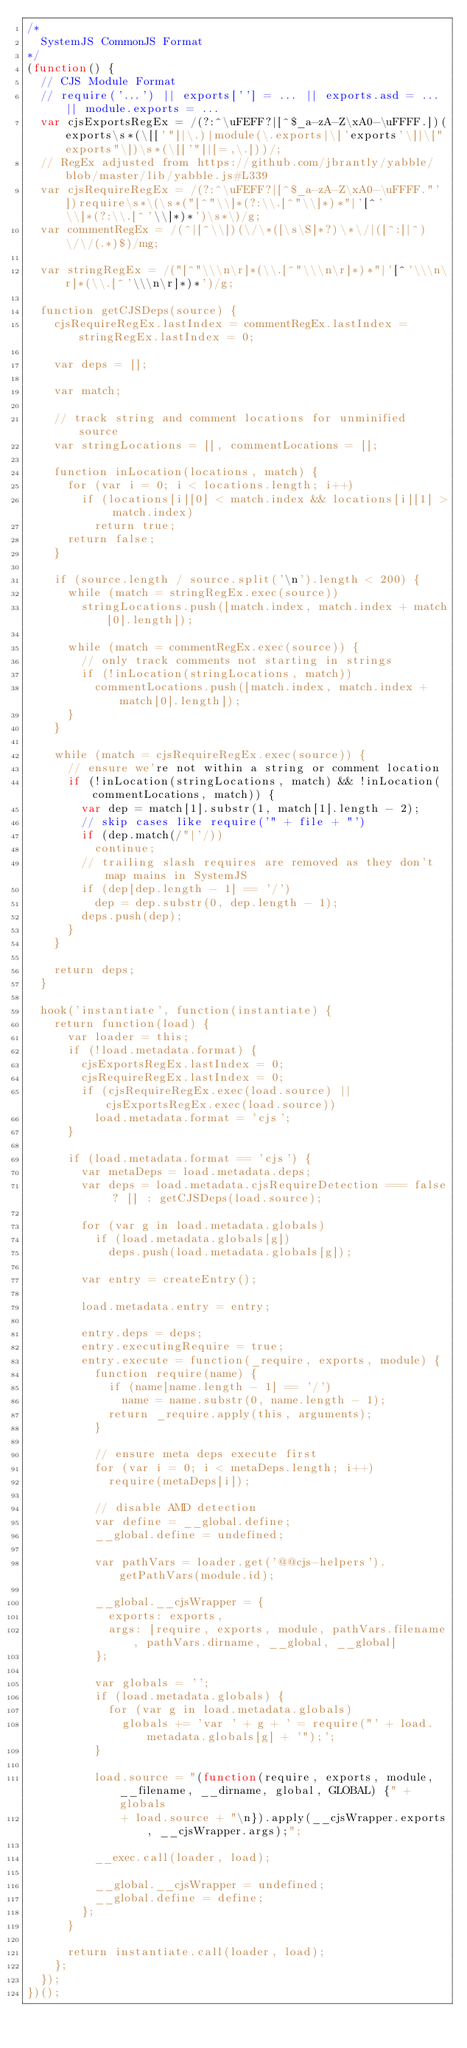Convert code to text. <code><loc_0><loc_0><loc_500><loc_500><_JavaScript_>/*
  SystemJS CommonJS Format
*/
(function() {
  // CJS Module Format
  // require('...') || exports[''] = ... || exports.asd = ... || module.exports = ...
  var cjsExportsRegEx = /(?:^\uFEFF?|[^$_a-zA-Z\xA0-\uFFFF.])(exports\s*(\[['"]|\.)|module(\.exports|\['exports'\]|\["exports"\])\s*(\[['"]|[=,\.]))/;
  // RegEx adjusted from https://github.com/jbrantly/yabble/blob/master/lib/yabble.js#L339
  var cjsRequireRegEx = /(?:^\uFEFF?|[^$_a-zA-Z\xA0-\uFFFF."'])require\s*\(\s*("[^"\\]*(?:\\.[^"\\]*)*"|'[^'\\]*(?:\\.[^'\\]*)*')\s*\)/g;
  var commentRegEx = /(^|[^\\])(\/\*([\s\S]*?)\*\/|([^:]|^)\/\/(.*)$)/mg;

  var stringRegEx = /("[^"\\\n\r]*(\\.[^"\\\n\r]*)*"|'[^'\\\n\r]*(\\.[^'\\\n\r]*)*')/g;

  function getCJSDeps(source) {
    cjsRequireRegEx.lastIndex = commentRegEx.lastIndex = stringRegEx.lastIndex = 0;

    var deps = [];

    var match;

    // track string and comment locations for unminified source    
    var stringLocations = [], commentLocations = [];

    function inLocation(locations, match) {
      for (var i = 0; i < locations.length; i++)
        if (locations[i][0] < match.index && locations[i][1] > match.index)
          return true;
      return false;
    }

    if (source.length / source.split('\n').length < 200) {
      while (match = stringRegEx.exec(source))
        stringLocations.push([match.index, match.index + match[0].length]);
      
      while (match = commentRegEx.exec(source)) {
        // only track comments not starting in strings
        if (!inLocation(stringLocations, match))
          commentLocations.push([match.index, match.index + match[0].length]);
      }
    }

    while (match = cjsRequireRegEx.exec(source)) {
      // ensure we're not within a string or comment location
      if (!inLocation(stringLocations, match) && !inLocation(commentLocations, match)) {
        var dep = match[1].substr(1, match[1].length - 2);
        // skip cases like require('" + file + "')
        if (dep.match(/"|'/))
          continue;
        // trailing slash requires are removed as they don't map mains in SystemJS
        if (dep[dep.length - 1] == '/')
          dep = dep.substr(0, dep.length - 1);
        deps.push(dep);
      }
    }

    return deps;
  }

  hook('instantiate', function(instantiate) {
    return function(load) {
      var loader = this;
      if (!load.metadata.format) {
        cjsExportsRegEx.lastIndex = 0;
        cjsRequireRegEx.lastIndex = 0;
        if (cjsRequireRegEx.exec(load.source) || cjsExportsRegEx.exec(load.source))
          load.metadata.format = 'cjs';
      }

      if (load.metadata.format == 'cjs') {
        var metaDeps = load.metadata.deps;
        var deps = load.metadata.cjsRequireDetection === false ? [] : getCJSDeps(load.source);

        for (var g in load.metadata.globals)
          if (load.metadata.globals[g])
            deps.push(load.metadata.globals[g]);

        var entry = createEntry();

        load.metadata.entry = entry;

        entry.deps = deps;
        entry.executingRequire = true;
        entry.execute = function(_require, exports, module) {
          function require(name) {
            if (name[name.length - 1] == '/')
              name = name.substr(0, name.length - 1);
            return _require.apply(this, arguments);
          }

          // ensure meta deps execute first
          for (var i = 0; i < metaDeps.length; i++)
            require(metaDeps[i]);

          // disable AMD detection
          var define = __global.define;
          __global.define = undefined;

          var pathVars = loader.get('@@cjs-helpers').getPathVars(module.id);

          __global.__cjsWrapper = {
            exports: exports,
            args: [require, exports, module, pathVars.filename, pathVars.dirname, __global, __global]
          };

          var globals = '';
          if (load.metadata.globals) {
            for (var g in load.metadata.globals)
              globals += 'var ' + g + ' = require("' + load.metadata.globals[g] + '");';
          }

          load.source = "(function(require, exports, module, __filename, __dirname, global, GLOBAL) {" + globals
              + load.source + "\n}).apply(__cjsWrapper.exports, __cjsWrapper.args);";

          __exec.call(loader, load);

          __global.__cjsWrapper = undefined;
          __global.define = define;
        };
      }

      return instantiate.call(loader, load);
    };
  });
})();
</code> 